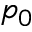<formula> <loc_0><loc_0><loc_500><loc_500>p _ { 0 }</formula> 